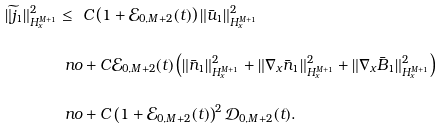Convert formula to latex. <formula><loc_0><loc_0><loc_500><loc_500>\| \widetilde { j } _ { 1 } \| ^ { 2 } _ { H ^ { M + 1 } _ { x } } \leq \ & C \left ( 1 + \mathcal { E } _ { 0 , M + 2 } ( t ) \right ) \| \bar { u } _ { 1 } \| ^ { 2 } _ { H ^ { M + 1 } _ { x } } \\ \ n o & + C \mathcal { E } _ { 0 , M + 2 } ( t ) \left ( \| \bar { n } _ { 1 } \| ^ { 2 } _ { H ^ { M + 1 } _ { x } } + \| \nabla _ { x } \bar { n } _ { 1 } \| ^ { 2 } _ { H ^ { M + 1 } _ { x } } + \| \nabla _ { x } \bar { B } _ { 1 } \| ^ { 2 } _ { H ^ { M + 1 } _ { x } } \right ) \\ \ n o & + C \left ( 1 + \mathcal { E } _ { 0 , M + 2 } ( t ) \right ) ^ { 2 } \mathcal { D } _ { 0 , M + 2 } ( t ) .</formula> 